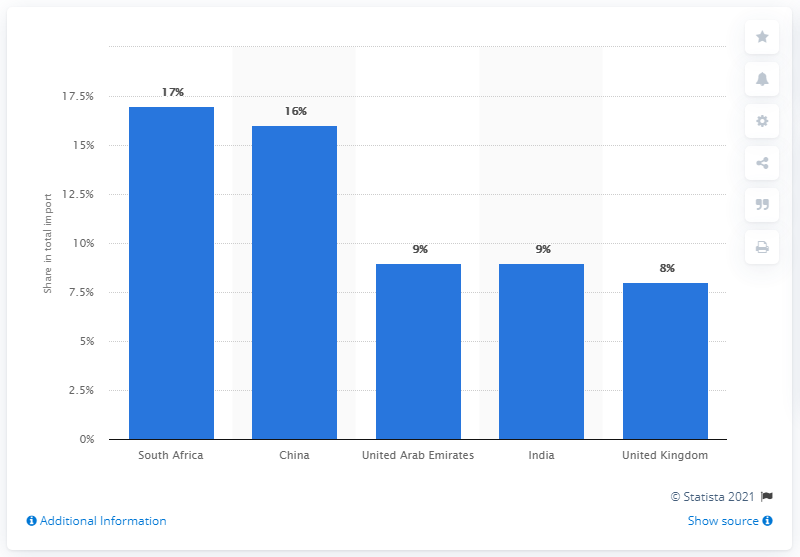Outline some significant characteristics in this image. In 2019, Malawi's most important import partner was South Africa. 